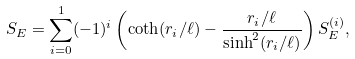Convert formula to latex. <formula><loc_0><loc_0><loc_500><loc_500>S _ { E } = \sum _ { i = 0 } ^ { 1 } ( - 1 ) ^ { i } \left ( \coth ( r _ { i } / \ell ) - { \frac { r _ { i } / \ell } { \sinh ^ { 2 } ( r _ { i } / \ell ) } } \right ) S _ { E } ^ { ( i ) } ,</formula> 